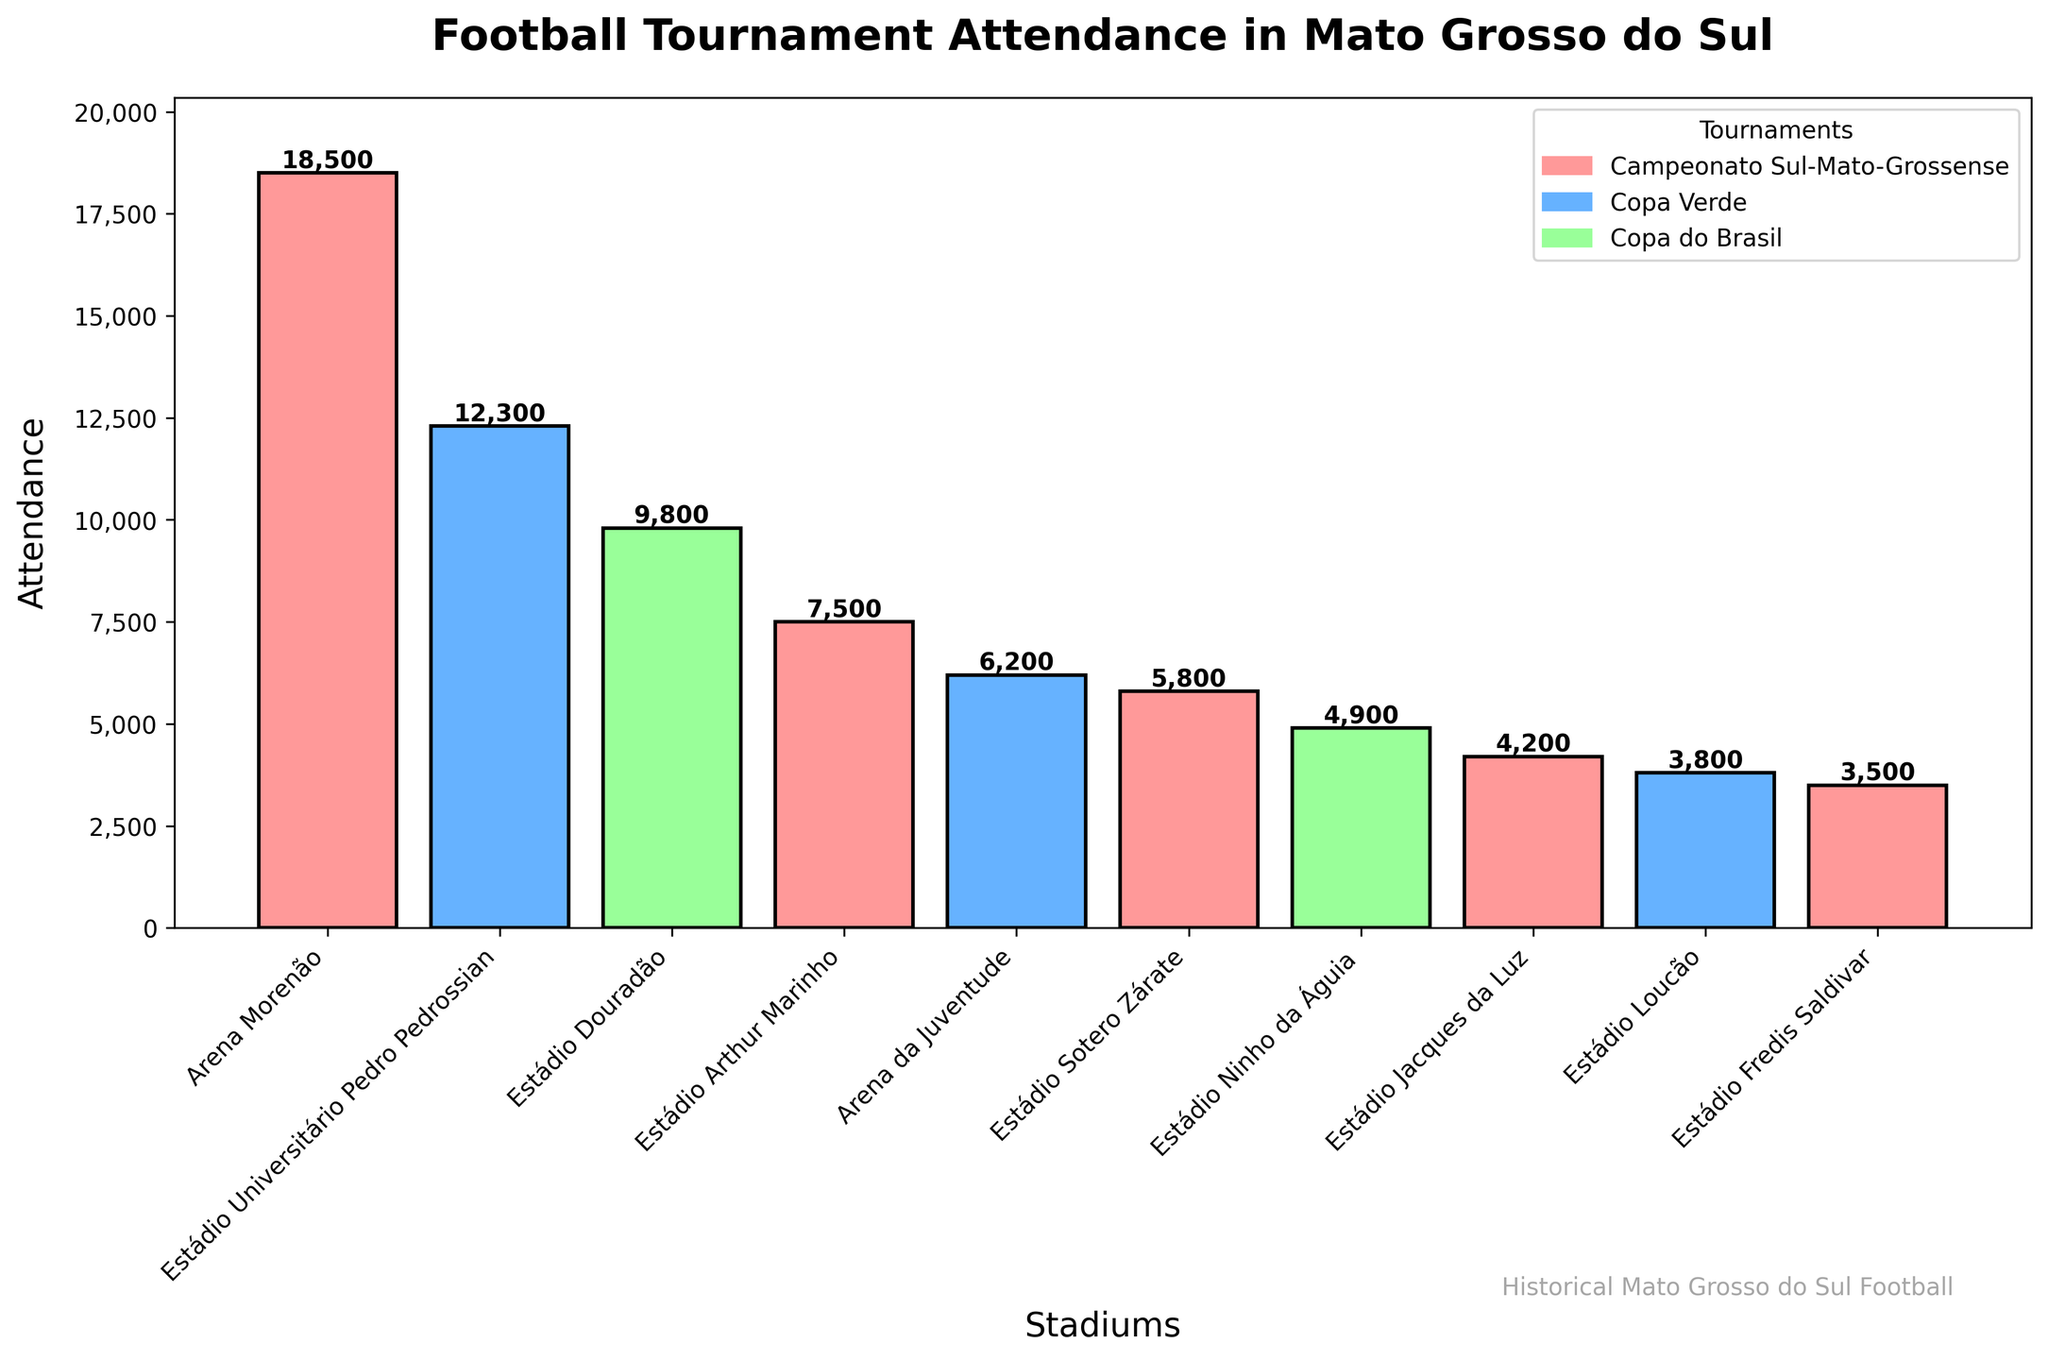Which stadium had the highest attendance? The highest bar in the chart represents the stadium with the highest attendance. It is the Arena Morenão.
Answer: Arena Morenão Which tournament had the highest attendance in 2019? In 2019, the chart shows two bars: one for the Campeonato Sul-Mato-Grossense at Arena Morenão and another for the Copa Verde at Arena da Juventude. The bar for Arena Morenão is higher.
Answer: Campeonato Sul-Mato-Grossense Which stadium hosted the Copa do Brasil tournament in 2020? The label for the year 2020 in the chart corresponds to the Estádio Douradão.
Answer: Estádio Douradão What is the total attendance for the Campeonato Sul-Mato-Grossense across all years? Sum the attendance figures for the Campeonato Sul-Mato-Grossense: 2019 (18,500 at Arena Morenão), 2021 (7,500 at Estádio Arthur Marinho), 2018 (5,800 at Estádio Sotero Zárate), 2020 (4,200 at Estádio Jacques da Luz), and 2017 (3,500 at Estádio Fredis Saldivar). So, 18,500 + 7,500 + 5,800 + 4,200 + 3,500 = 39,500.
Answer: 39,500 Is there a stadium that hosted more than one different tournament? By examining which stadium names appear multiple times with different tournament labels, none of the stadiums hosted more than one different tournament.
Answer: No How does the attendance at Estádio Sotero Zárate in 2018 compare to Estádio Loucão in 2017? Compare the height of the bars for Estádio Sotero Zárate in 2018 (5,800) and Estádio Loucão in 2017 (3,800). Estádio Sotero Zárate's attendance is higher.
Answer: Higher What is the average attendance for the Copa Verde tournaments? Find the bars for Copa Verde and calculate the average. Sum the attendances (12,300 + 6,200 + 3,800) and divide by the number of entries (3). So, (12,300 + 6,200 + 3,800) / 3 = 7,433.33.
Answer: 7,433.33 Which tournament had the lowest attendance, and at which stadium? The shortest bar represents the lowest attendance, which is for the Campeonato Sul-Mato-Grossense at Estádio Fredis Saldivar in 2017 with 3,500 attendees.
Answer: Campeonato Sul-Mato-Grossense, Estádio Fredis Saldivar What is the difference in attendance between Estádio Universitário Pedro Pedrossian and Estádio Douradão? Subtract the attendance figures for Estádio Douradão (9,800) from Estádio Universitário Pedro Pedrossian (12,300). So, 12,300 - 9,800 = 2,500.
Answer: 2,500 